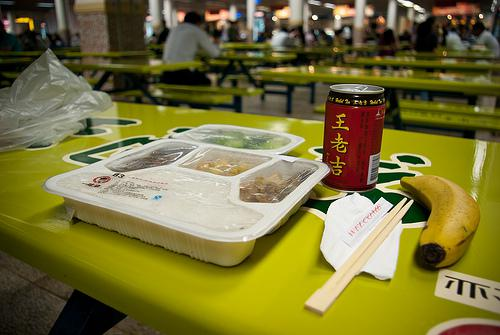Question: what is on the napkin?
Choices:
A. A bowl.
B. Rice.
C. Chicken.
D. Chopsticks.
Answer with the letter. Answer: D Question: where is the banana?
Choices:
A. In the bowl.
B. On the table.
C. On a plate.
D. On a napkin.
Answer with the letter. Answer: B Question: what is under the chopsticks?
Choices:
A. A napkin.
B. A plate.
C. The table.
D. Rice.
Answer with the letter. Answer: A 